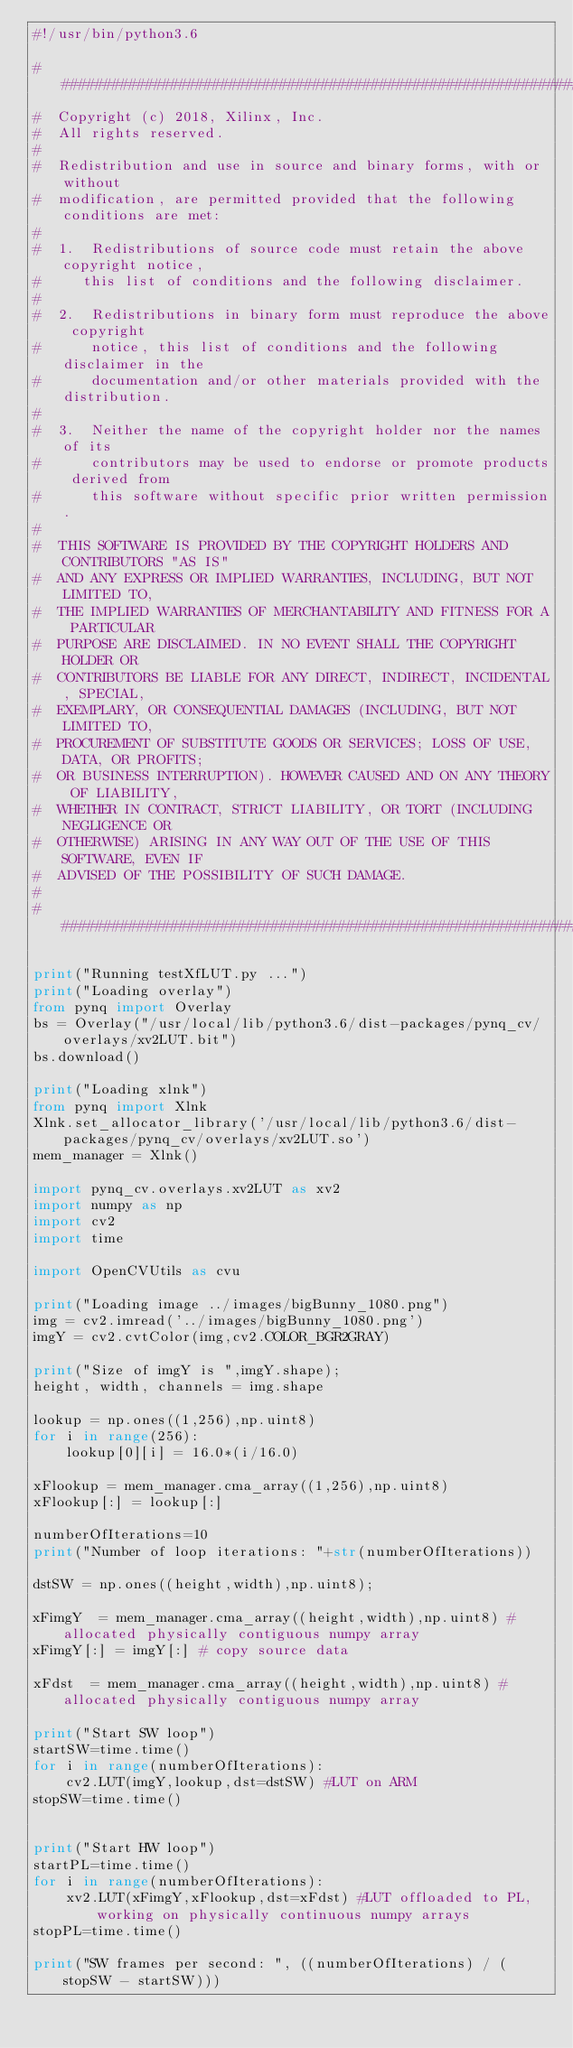<code> <loc_0><loc_0><loc_500><loc_500><_Python_>#!/usr/bin/python3.6

###############################################################################
#  Copyright (c) 2018, Xilinx, Inc.
#  All rights reserved.
# 
#  Redistribution and use in source and binary forms, with or without 
#  modification, are permitted provided that the following conditions are met:
#
#  1.  Redistributions of source code must retain the above copyright notice, 
#     this list of conditions and the following disclaimer.
#
#  2.  Redistributions in binary form must reproduce the above copyright 
#      notice, this list of conditions and the following disclaimer in the 
#      documentation and/or other materials provided with the distribution.
#
#  3.  Neither the name of the copyright holder nor the names of its 
#      contributors may be used to endorse or promote products derived from 
#      this software without specific prior written permission.
#
#  THIS SOFTWARE IS PROVIDED BY THE COPYRIGHT HOLDERS AND CONTRIBUTORS "AS IS"
#  AND ANY EXPRESS OR IMPLIED WARRANTIES, INCLUDING, BUT NOT LIMITED TO, 
#  THE IMPLIED WARRANTIES OF MERCHANTABILITY AND FITNESS FOR A PARTICULAR 
#  PURPOSE ARE DISCLAIMED. IN NO EVENT SHALL THE COPYRIGHT HOLDER OR 
#  CONTRIBUTORS BE LIABLE FOR ANY DIRECT, INDIRECT, INCIDENTAL, SPECIAL, 
#  EXEMPLARY, OR CONSEQUENTIAL DAMAGES (INCLUDING, BUT NOT LIMITED TO, 
#  PROCUREMENT OF SUBSTITUTE GOODS OR SERVICES; LOSS OF USE, DATA, OR PROFITS;
#  OR BUSINESS INTERRUPTION). HOWEVER CAUSED AND ON ANY THEORY OF LIABILITY, 
#  WHETHER IN CONTRACT, STRICT LIABILITY, OR TORT (INCLUDING NEGLIGENCE OR 
#  OTHERWISE) ARISING IN ANY WAY OUT OF THE USE OF THIS SOFTWARE, EVEN IF 
#  ADVISED OF THE POSSIBILITY OF SUCH DAMAGE.
#
###############################################################################

print("Running testXfLUT.py ...")
print("Loading overlay")
from pynq import Overlay
bs = Overlay("/usr/local/lib/python3.6/dist-packages/pynq_cv/overlays/xv2LUT.bit")
bs.download()

print("Loading xlnk")
from pynq import Xlnk
Xlnk.set_allocator_library('/usr/local/lib/python3.6/dist-packages/pynq_cv/overlays/xv2LUT.so')
mem_manager = Xlnk()

import pynq_cv.overlays.xv2LUT as xv2
import numpy as np
import cv2
import time

import OpenCVUtils as cvu

print("Loading image ../images/bigBunny_1080.png")
img = cv2.imread('../images/bigBunny_1080.png')
imgY = cv2.cvtColor(img,cv2.COLOR_BGR2GRAY)

print("Size of imgY is ",imgY.shape);
height, width, channels = img.shape

lookup = np.ones((1,256),np.uint8)
for i in range(256):
    lookup[0][i] = 16.0*(i/16.0)

xFlookup = mem_manager.cma_array((1,256),np.uint8)
xFlookup[:] = lookup[:]

numberOfIterations=10
print("Number of loop iterations: "+str(numberOfIterations))

dstSW = np.ones((height,width),np.uint8);

xFimgY  = mem_manager.cma_array((height,width),np.uint8) #allocated physically contiguous numpy array 
xFimgY[:] = imgY[:] # copy source data

xFdst  = mem_manager.cma_array((height,width),np.uint8) #allocated physically contiguous numpy array

print("Start SW loop")
startSW=time.time()
for i in range(numberOfIterations):
    cv2.LUT(imgY,lookup,dst=dstSW) #LUT on ARM
stopSW=time.time()


print("Start HW loop")
startPL=time.time()
for i in range(numberOfIterations):
    xv2.LUT(xFimgY,xFlookup,dst=xFdst) #LUT offloaded to PL, working on physically continuous numpy arrays
stopPL=time.time()
    
print("SW frames per second: ", ((numberOfIterations) / (stopSW - startSW)))</code> 